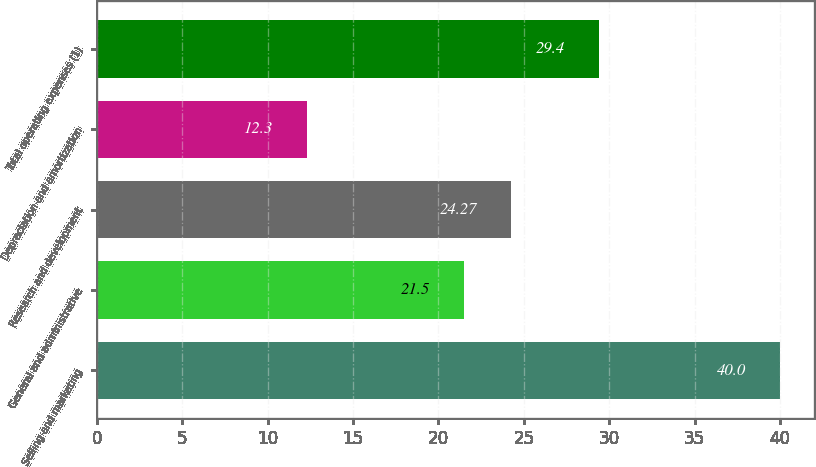Convert chart to OTSL. <chart><loc_0><loc_0><loc_500><loc_500><bar_chart><fcel>Selling and marketing<fcel>General and administrative<fcel>Research and development<fcel>Depreciation and amortization<fcel>Total operating expenses (1)<nl><fcel>40<fcel>21.5<fcel>24.27<fcel>12.3<fcel>29.4<nl></chart> 